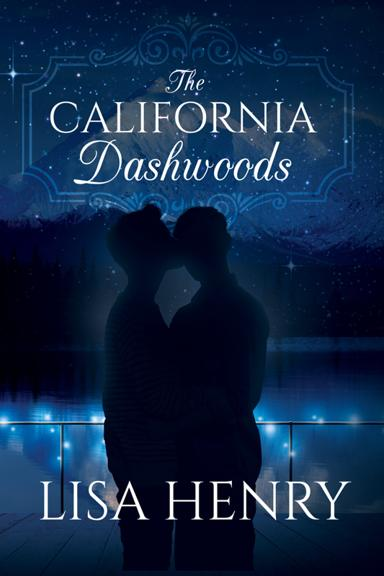Describe the content of the poster. The poster displays a poignant scene with two silhouettes kissing under a starlit sky, complemented by a captivating blue palette that evokes a sense of mystery and romance. This visual likely represents significant themes or moments from 'The California Dashwoods.' 